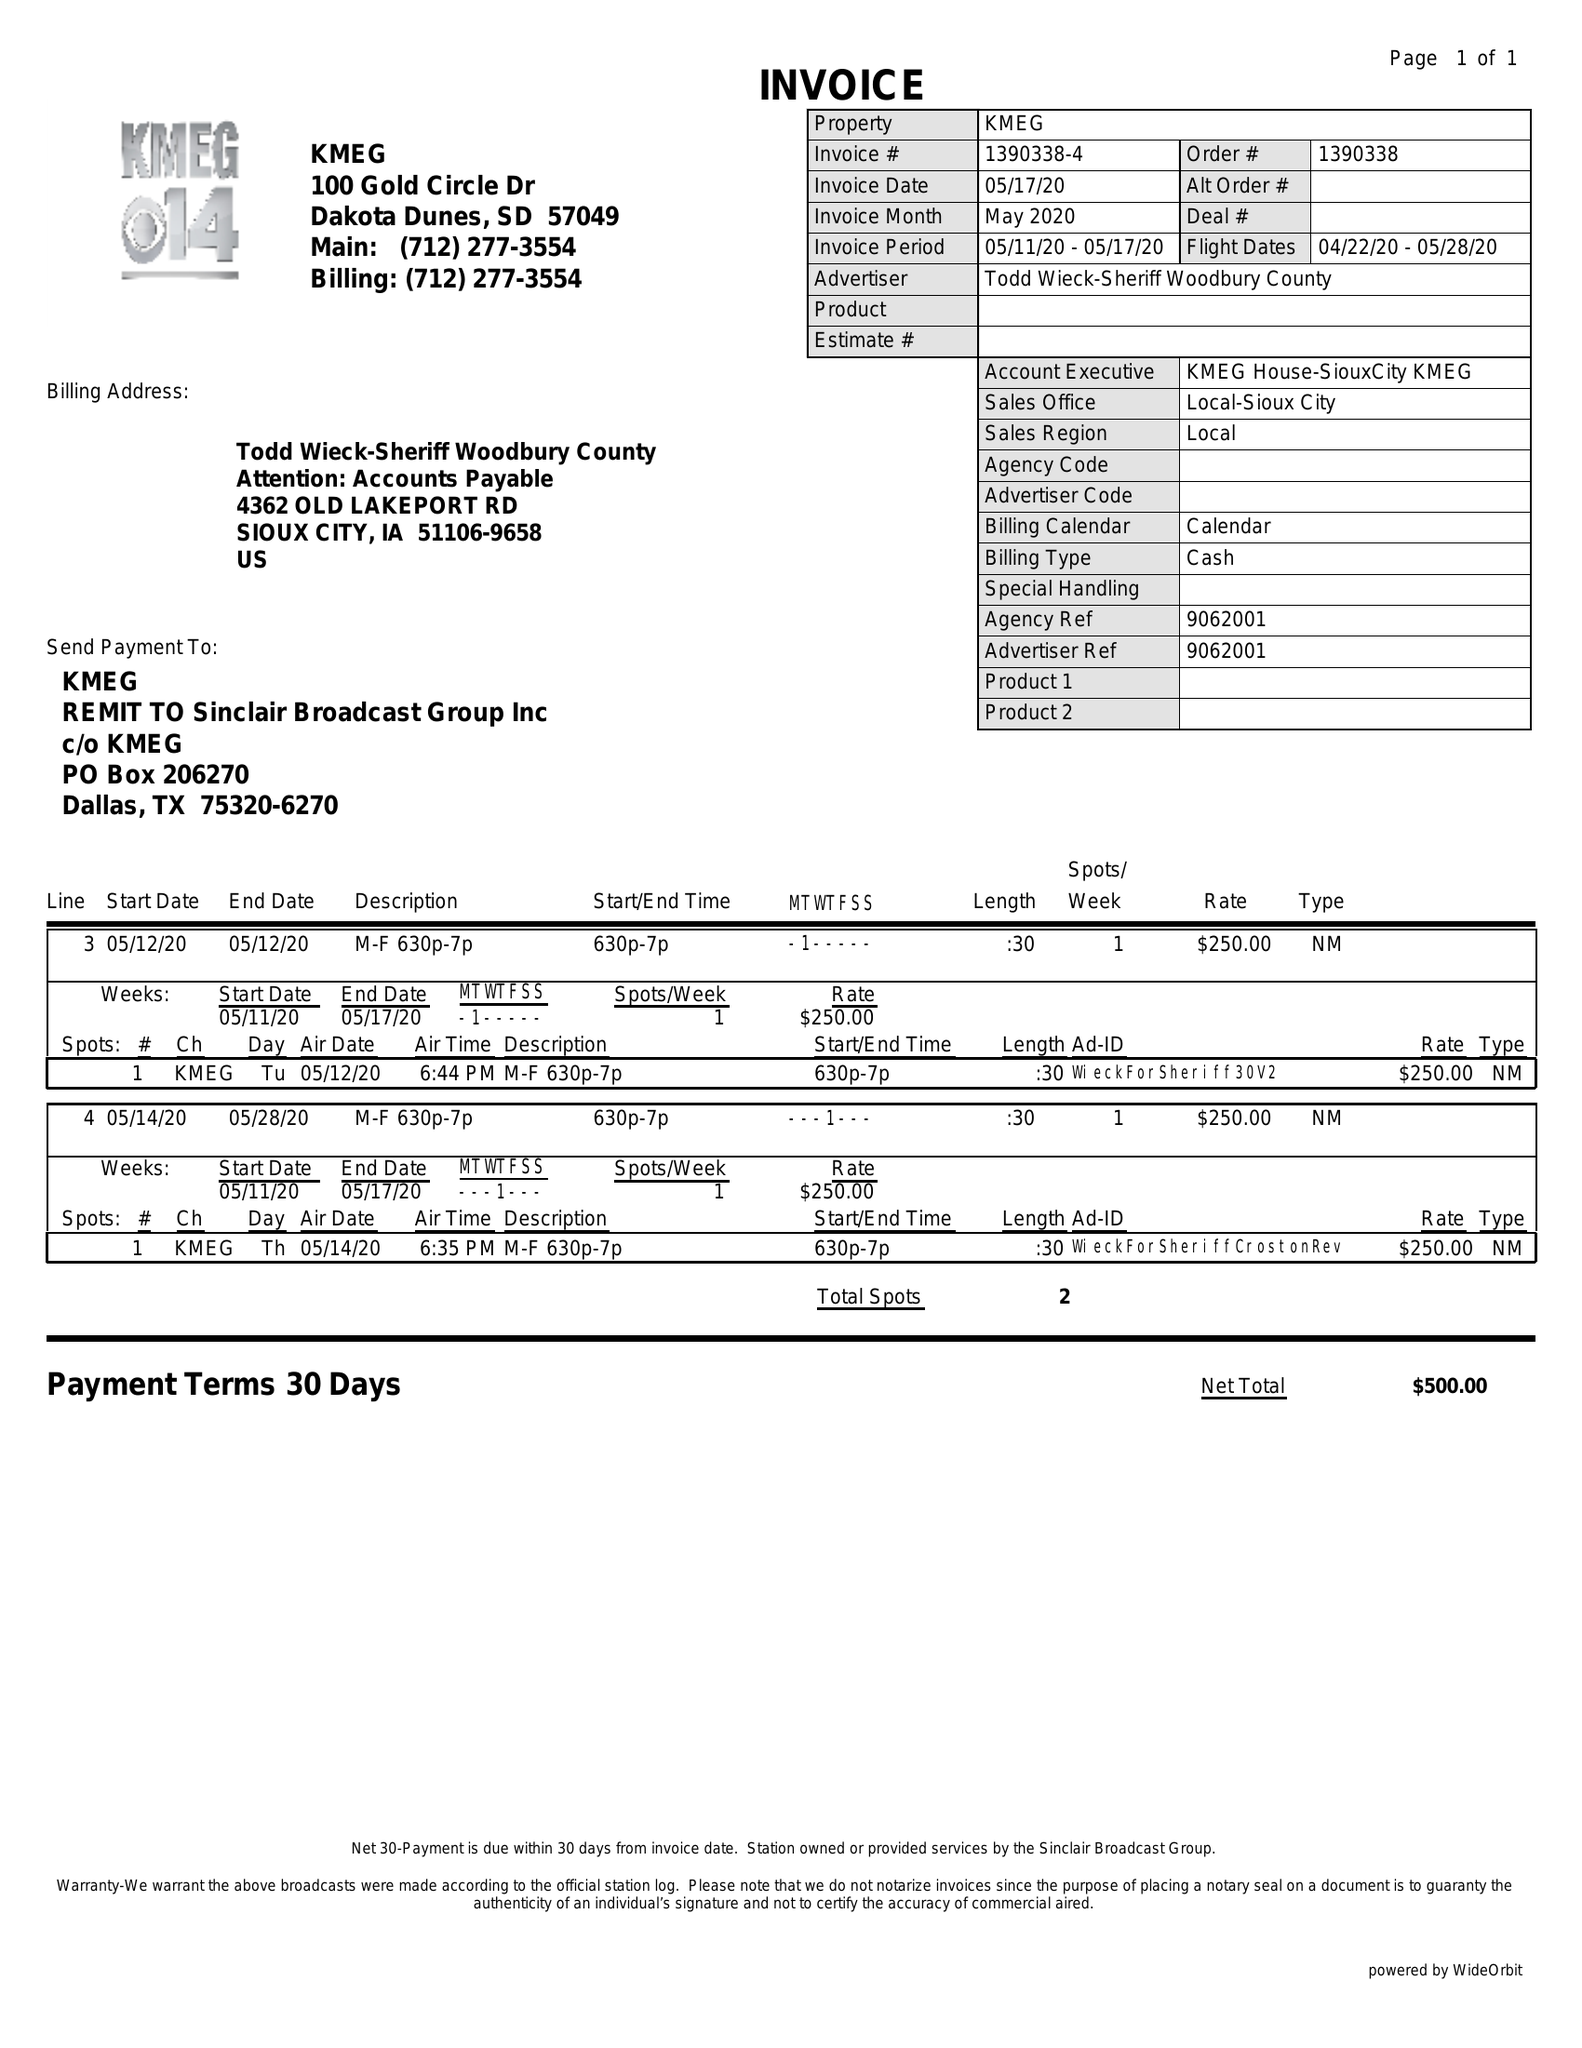What is the value for the gross_amount?
Answer the question using a single word or phrase. 500.00 